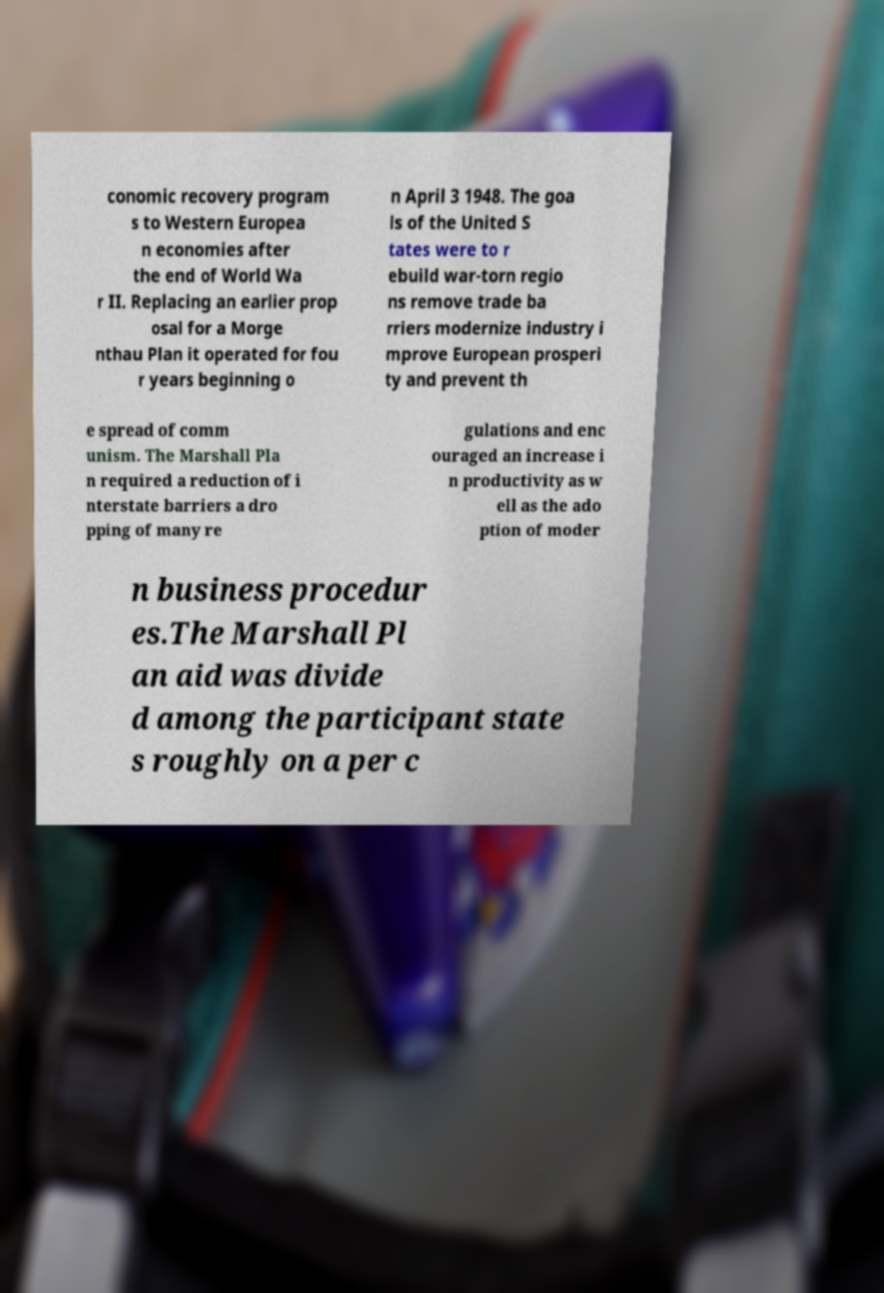Could you extract and type out the text from this image? conomic recovery program s to Western Europea n economies after the end of World Wa r II. Replacing an earlier prop osal for a Morge nthau Plan it operated for fou r years beginning o n April 3 1948. The goa ls of the United S tates were to r ebuild war-torn regio ns remove trade ba rriers modernize industry i mprove European prosperi ty and prevent th e spread of comm unism. The Marshall Pla n required a reduction of i nterstate barriers a dro pping of many re gulations and enc ouraged an increase i n productivity as w ell as the ado ption of moder n business procedur es.The Marshall Pl an aid was divide d among the participant state s roughly on a per c 